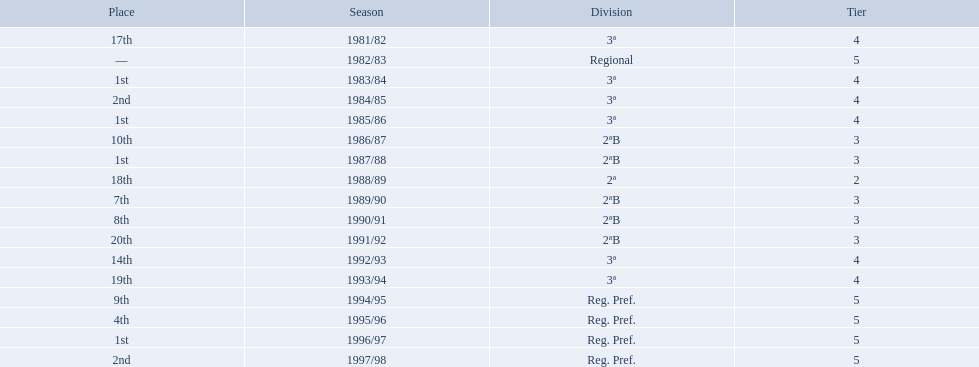Which years did the team have a season? 1981/82, 1982/83, 1983/84, 1984/85, 1985/86, 1986/87, 1987/88, 1988/89, 1989/90, 1990/91, 1991/92, 1992/93, 1993/94, 1994/95, 1995/96, 1996/97, 1997/98. Which of those years did the team place outside the top 10? 1981/82, 1988/89, 1991/92, 1992/93, 1993/94. Which of the years in which the team placed outside the top 10 did they have their worst performance? 1991/92. 